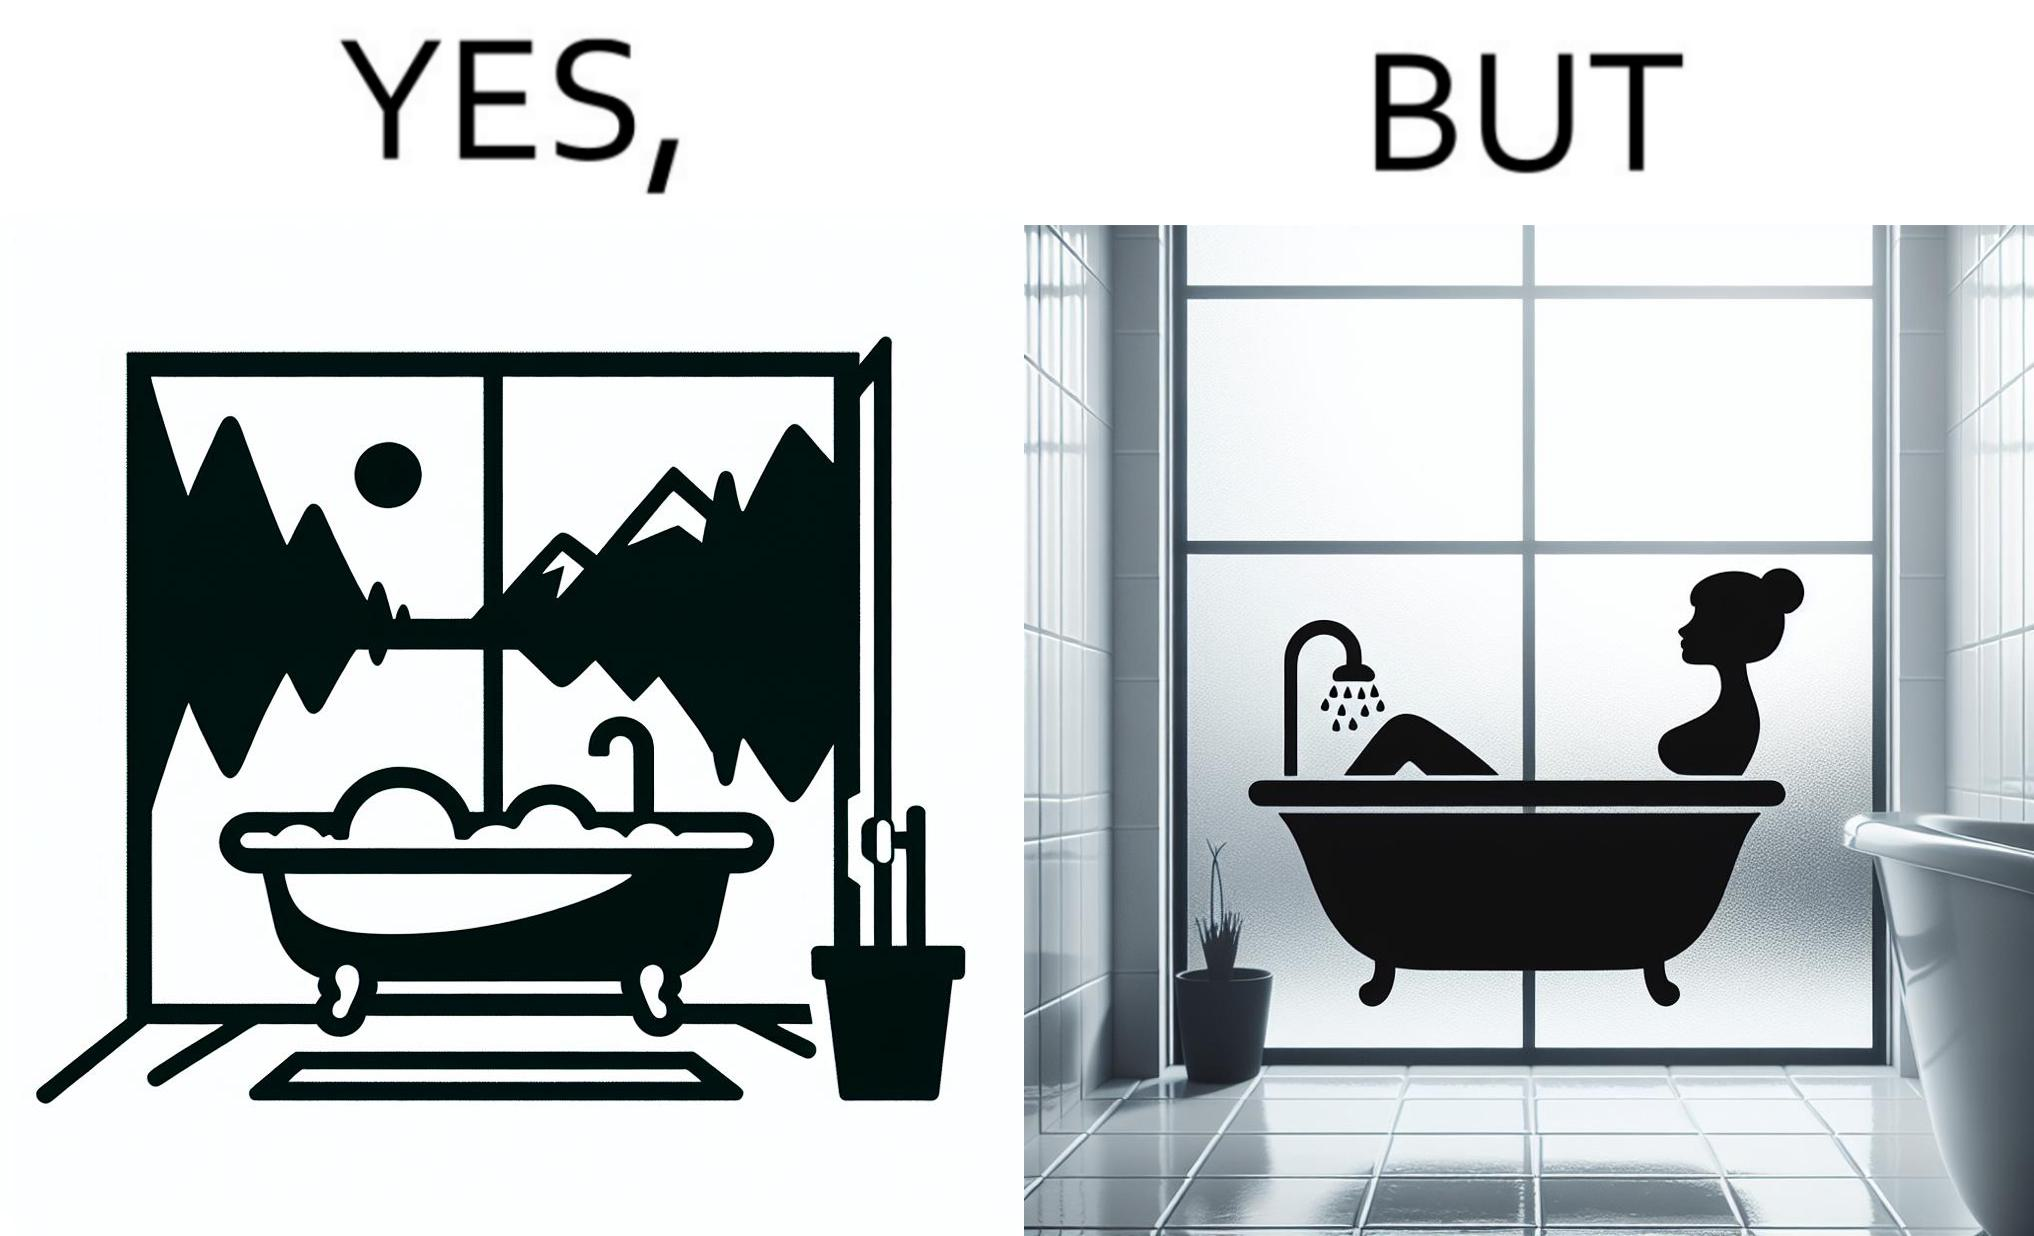Describe the contrast between the left and right parts of this image. In the left part of the image: a bathtub by the side of a window which has a very scenic view of lake and mountains. In the right part of the image: a woman bathing in a bathtub, while the window glasses are foggy from the steam of the hot water. 